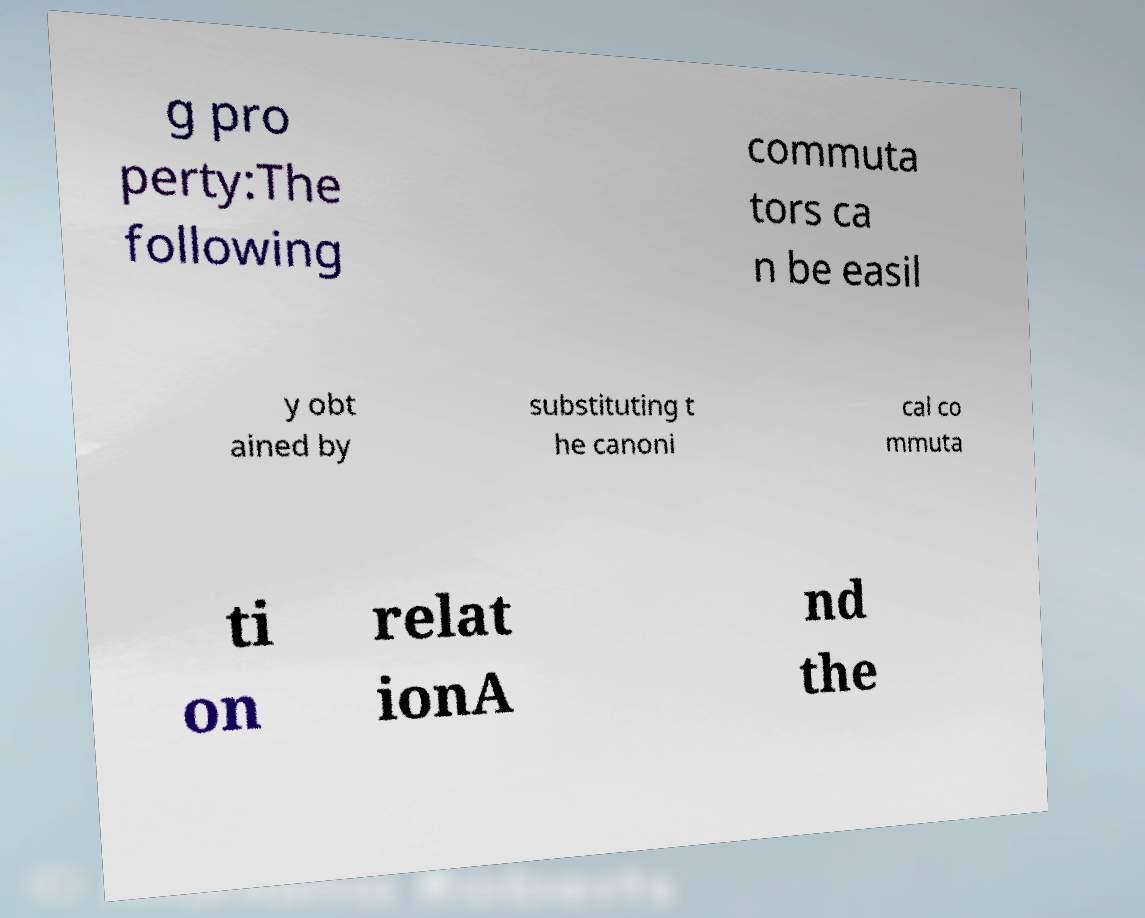Please read and relay the text visible in this image. What does it say? g pro perty:The following commuta tors ca n be easil y obt ained by substituting t he canoni cal co mmuta ti on relat ionA nd the 